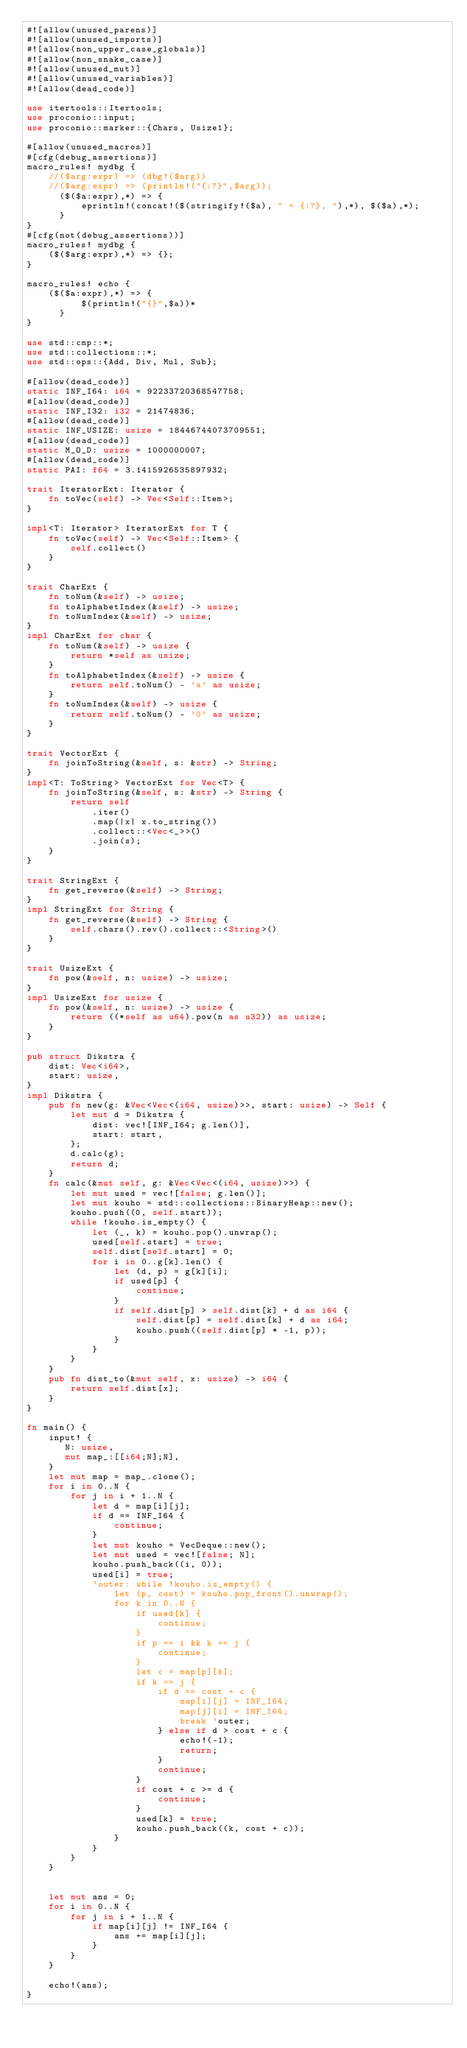<code> <loc_0><loc_0><loc_500><loc_500><_Rust_>#![allow(unused_parens)]
#![allow(unused_imports)]
#![allow(non_upper_case_globals)]
#![allow(non_snake_case)]
#![allow(unused_mut)]
#![allow(unused_variables)]
#![allow(dead_code)]

use itertools::Itertools;
use proconio::input;
use proconio::marker::{Chars, Usize1};

#[allow(unused_macros)]
#[cfg(debug_assertions)]
macro_rules! mydbg {
    //($arg:expr) => (dbg!($arg))
    //($arg:expr) => (println!("{:?}",$arg));
      ($($a:expr),*) => {
          eprintln!(concat!($(stringify!($a), " = {:?}, "),*), $($a),*);
      }
}
#[cfg(not(debug_assertions))]
macro_rules! mydbg {
    ($($arg:expr),*) => {};
}

macro_rules! echo {
    ($($a:expr),*) => {
          $(println!("{}",$a))*
      }
}

use std::cmp::*;
use std::collections::*;
use std::ops::{Add, Div, Mul, Sub};

#[allow(dead_code)]
static INF_I64: i64 = 92233720368547758;
#[allow(dead_code)]
static INF_I32: i32 = 21474836;
#[allow(dead_code)]
static INF_USIZE: usize = 18446744073709551;
#[allow(dead_code)]
static M_O_D: usize = 1000000007;
#[allow(dead_code)]
static PAI: f64 = 3.1415926535897932;

trait IteratorExt: Iterator {
    fn toVec(self) -> Vec<Self::Item>;
}

impl<T: Iterator> IteratorExt for T {
    fn toVec(self) -> Vec<Self::Item> {
        self.collect()
    }
}

trait CharExt {
    fn toNum(&self) -> usize;
    fn toAlphabetIndex(&self) -> usize;
    fn toNumIndex(&self) -> usize;
}
impl CharExt for char {
    fn toNum(&self) -> usize {
        return *self as usize;
    }
    fn toAlphabetIndex(&self) -> usize {
        return self.toNum() - 'a' as usize;
    }
    fn toNumIndex(&self) -> usize {
        return self.toNum() - '0' as usize;
    }
}

trait VectorExt {
    fn joinToString(&self, s: &str) -> String;
}
impl<T: ToString> VectorExt for Vec<T> {
    fn joinToString(&self, s: &str) -> String {
        return self
            .iter()
            .map(|x| x.to_string())
            .collect::<Vec<_>>()
            .join(s);
    }
}

trait StringExt {
    fn get_reverse(&self) -> String;
}
impl StringExt for String {
    fn get_reverse(&self) -> String {
        self.chars().rev().collect::<String>()
    }
}

trait UsizeExt {
    fn pow(&self, n: usize) -> usize;
}
impl UsizeExt for usize {
    fn pow(&self, n: usize) -> usize {
        return ((*self as u64).pow(n as u32)) as usize;
    }
}

pub struct Dikstra {
    dist: Vec<i64>,
    start: usize,
}
impl Dikstra {
    pub fn new(g: &Vec<Vec<(i64, usize)>>, start: usize) -> Self {
        let mut d = Dikstra {
            dist: vec![INF_I64; g.len()],
            start: start,
        };
        d.calc(g);
        return d;
    }
    fn calc(&mut self, g: &Vec<Vec<(i64, usize)>>) {
        let mut used = vec![false; g.len()];
        let mut kouho = std::collections::BinaryHeap::new();
        kouho.push((0, self.start));
        while !kouho.is_empty() {
            let (_, k) = kouho.pop().unwrap();
            used[self.start] = true;
            self.dist[self.start] = 0;
            for i in 0..g[k].len() {
                let (d, p) = g[k][i];
                if used[p] {
                    continue;
                }
                if self.dist[p] > self.dist[k] + d as i64 {
                    self.dist[p] = self.dist[k] + d as i64;
                    kouho.push((self.dist[p] * -1, p));
                }
            }
        }
    }
    pub fn dist_to(&mut self, x: usize) -> i64 {
        return self.dist[x];
    }
}

fn main() {
    input! {
       N: usize,
       mut map_:[[i64;N];N],
    }
    let mut map = map_.clone();
    for i in 0..N {
        for j in i + 1..N {
            let d = map[i][j];
            if d == INF_I64 {
                continue;
            }
            let mut kouho = VecDeque::new();
            let mut used = vec![false; N];
            kouho.push_back((i, 0));
            used[i] = true;
            'outer: while !kouho.is_empty() {
                let (p, cost) = kouho.pop_front().unwrap();
                for k in 0..N {
                    if used[k] {
                        continue;
                    }
                    if p == i && k == j {
                        continue;
                    }
                    let c = map[p][k];
                    if k == j {
                        if d == cost + c {
                            map[i][j] = INF_I64;
                            map[j][i] = INF_I64;
                            break 'outer;
                        } else if d > cost + c {
                            echo!(-1);
                            return;
                        }
                        continue;
                    }
                    if cost + c >= d {
                        continue;
                    }
                    used[k] = true;
                    kouho.push_back((k, cost + c));
                }
            }
        }
    }
    

    let mut ans = 0;
    for i in 0..N {
        for j in i + 1..N {
            if map[i][j] != INF_I64 {
                ans += map[i][j];
            }
        }
    }

    echo!(ans);
}
</code> 